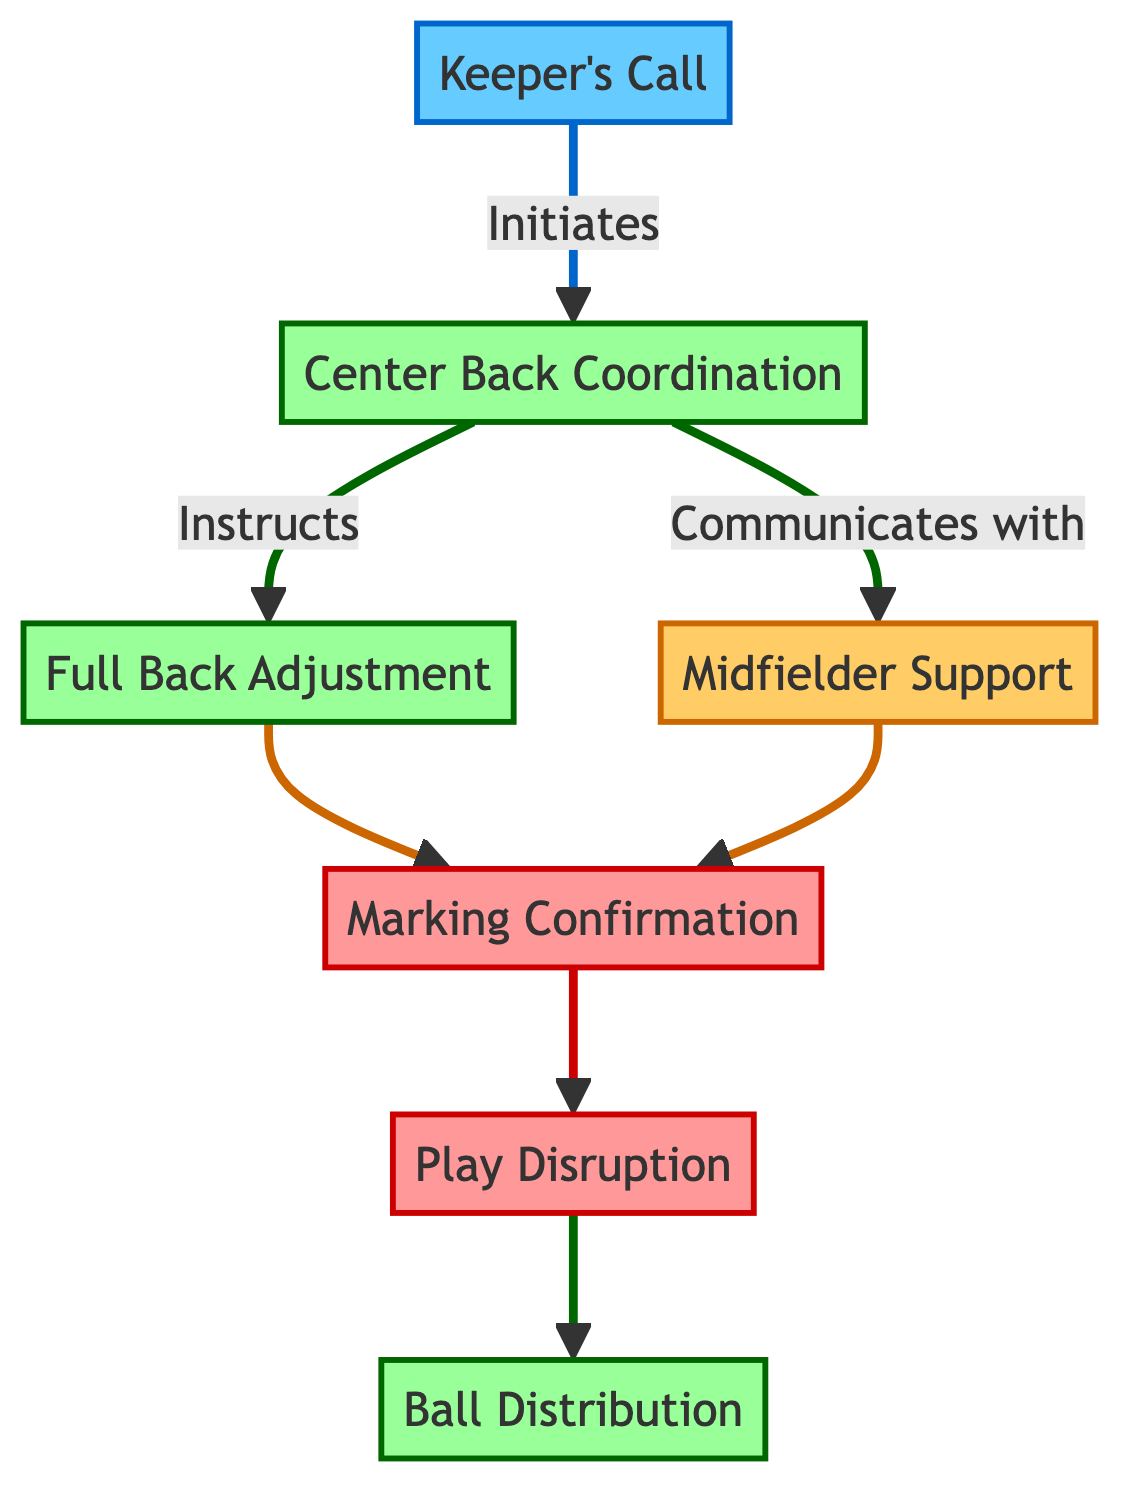What initiates the communication flow? The diagram starts with the "Keeper's Call" which indicates that the goalkeeper initiates the communication process.
Answer: Keeper's Call How many main steps are in the communication flow? By counting the steps listed in the diagram, there are a total of 7 main steps in the communication flow: Keeper's Call, Center Back Coordination, Full Back Adjustment, Midfielder Support, Marking Confirmation, Play Disruption, and Ball Distribution.
Answer: 7 Which step follows the "Marking Confirmation"? According to the flow, after "Marking Confirmation," the next step is "Play Disruption," indicating that marking duties are confirmed before defensive actions are coordinated.
Answer: Play Disruption Who confirms marking duties? The diagram states that "Each player" within the "Entire Defensive Line" is responsible for confirming their marking duties, thus involving all defenders.
Answer: Entire Defensive Line Which roles are involved in the "Ball Distribution" step? In the "Ball Distribution" step, the roles involved are Center Backs, Full Backs, and the Goalkeeper, indicating that these players handle the distribution after regaining possession.
Answer: Center Backs, Full Backs, Goalkeeper What is the main action in the "Play Disruption" step? The central actions involved in "Play Disruption" include intercepting passes, tackling attackers, and clearing the ball. This step focuses on coordinated defensive actions.
Answer: Intercept, tackle, clear Which step communicates with the "Midfielder Support"? The "Center Back Coordination" step communicates with "Midfielder Support," showing that center backs inform midfielders for additional coverage.
Answer: Center Back Coordination What is the dependency relationship between "Full Back Adjustment" and "Marking Confirmation"? The "Full Back Adjustment" step leads directly to "Marking Confirmation," indicating that adjustments in full back positioning are confirmed within the marking duties before further action is taken.
Answer: Leads to 